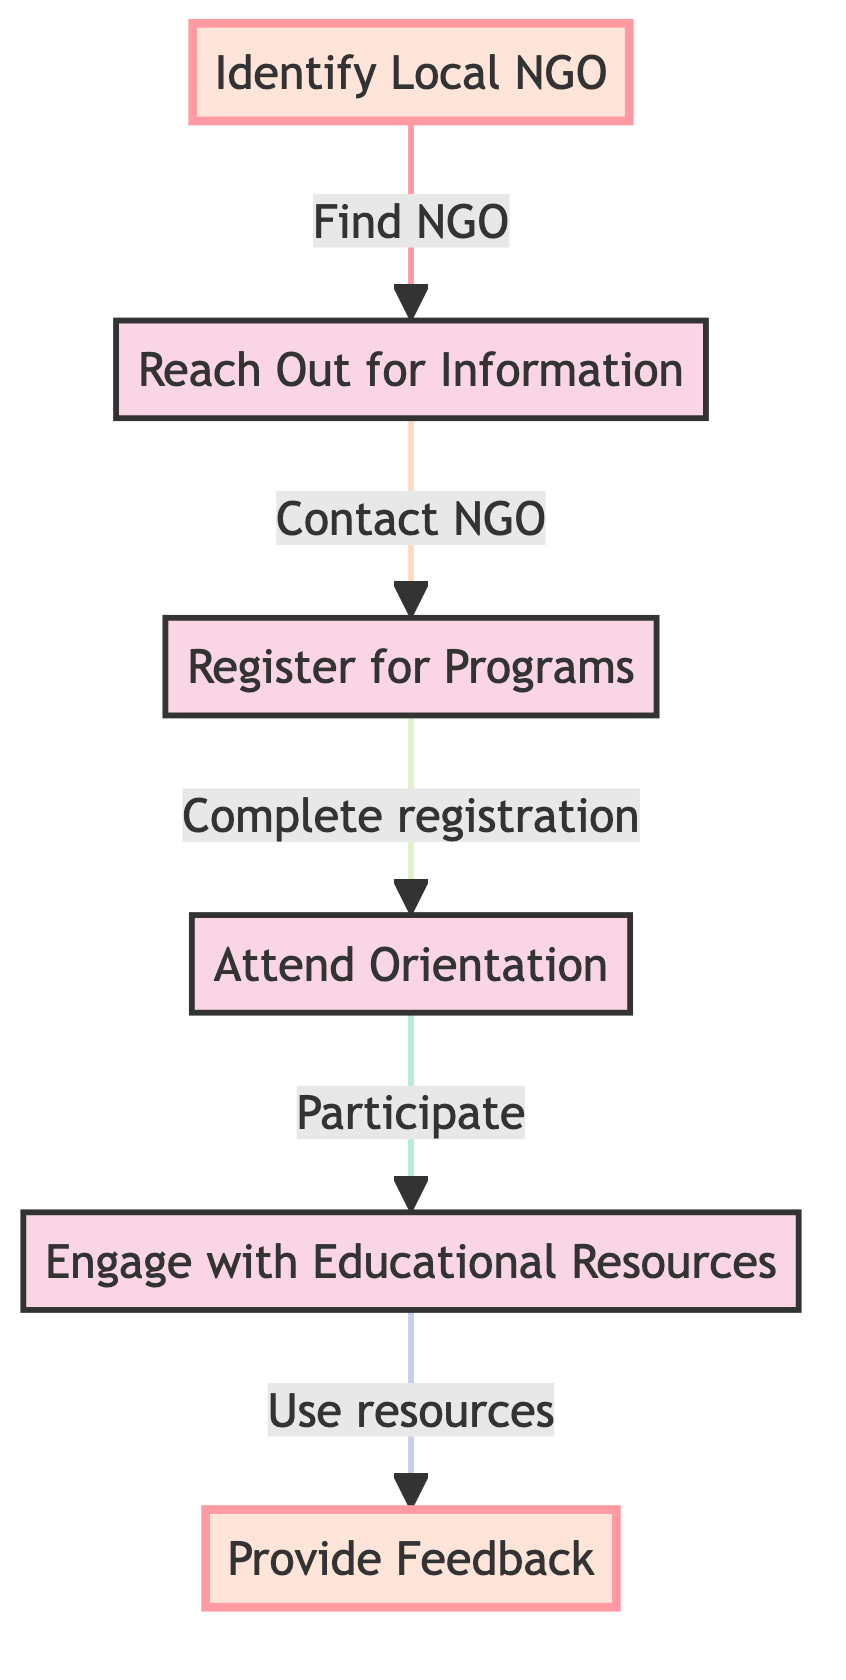What is the first step to access educational resources? The diagram indicates that the first step is "Identify Local NGO," which means you need to find a non-governmental organization that offers educational resources.
Answer: Identify Local NGO How many steps are there in total? By counting the nodes in the diagram, there are six distinct steps listed for accessing educational resources provided by NGOs.
Answer: Six What do you need to do after reaching out for information? The diagram shows that after reaching out for information, the next step is to "Register for Programs," which includes completing the registration process for the educational program.
Answer: Register for Programs What is the last step in this process? The last step according to the diagram is "Provide Feedback," which indicates that after engaging with the resources, you should share your experience with the NGO.
Answer: Provide Feedback Which step involves attending a session? The step that involves attending a session is called "Attend Orientation," where participants learn about the available resources and how to access them.
Answer: Attend Orientation What action should you take after engaging with educational resources? After engaging with educational resources, you are encouraged to "Provide Feedback" to help improve the NGO's programs for future students.
Answer: Provide Feedback What are the two highlighted steps in the flow chart? The highlighted steps in the flow chart are "Identify Local NGO" and "Provide Feedback," indicating these are particularly important steps in the process.
Answer: Identify Local NGO, Provide Feedback What should you do if you want more information about educational programs? You should "Reach Out for Information," by contacting the NGO through their phone number or visiting their office to inquire about available programs.
Answer: Reach Out for Information 